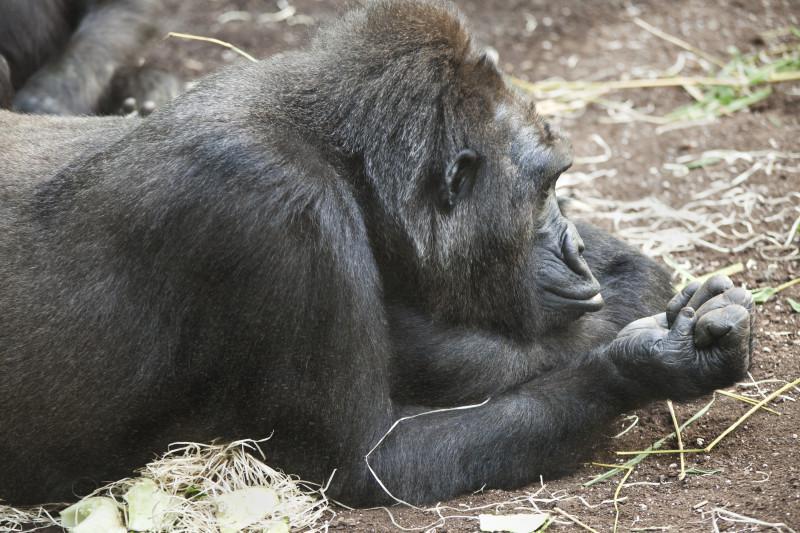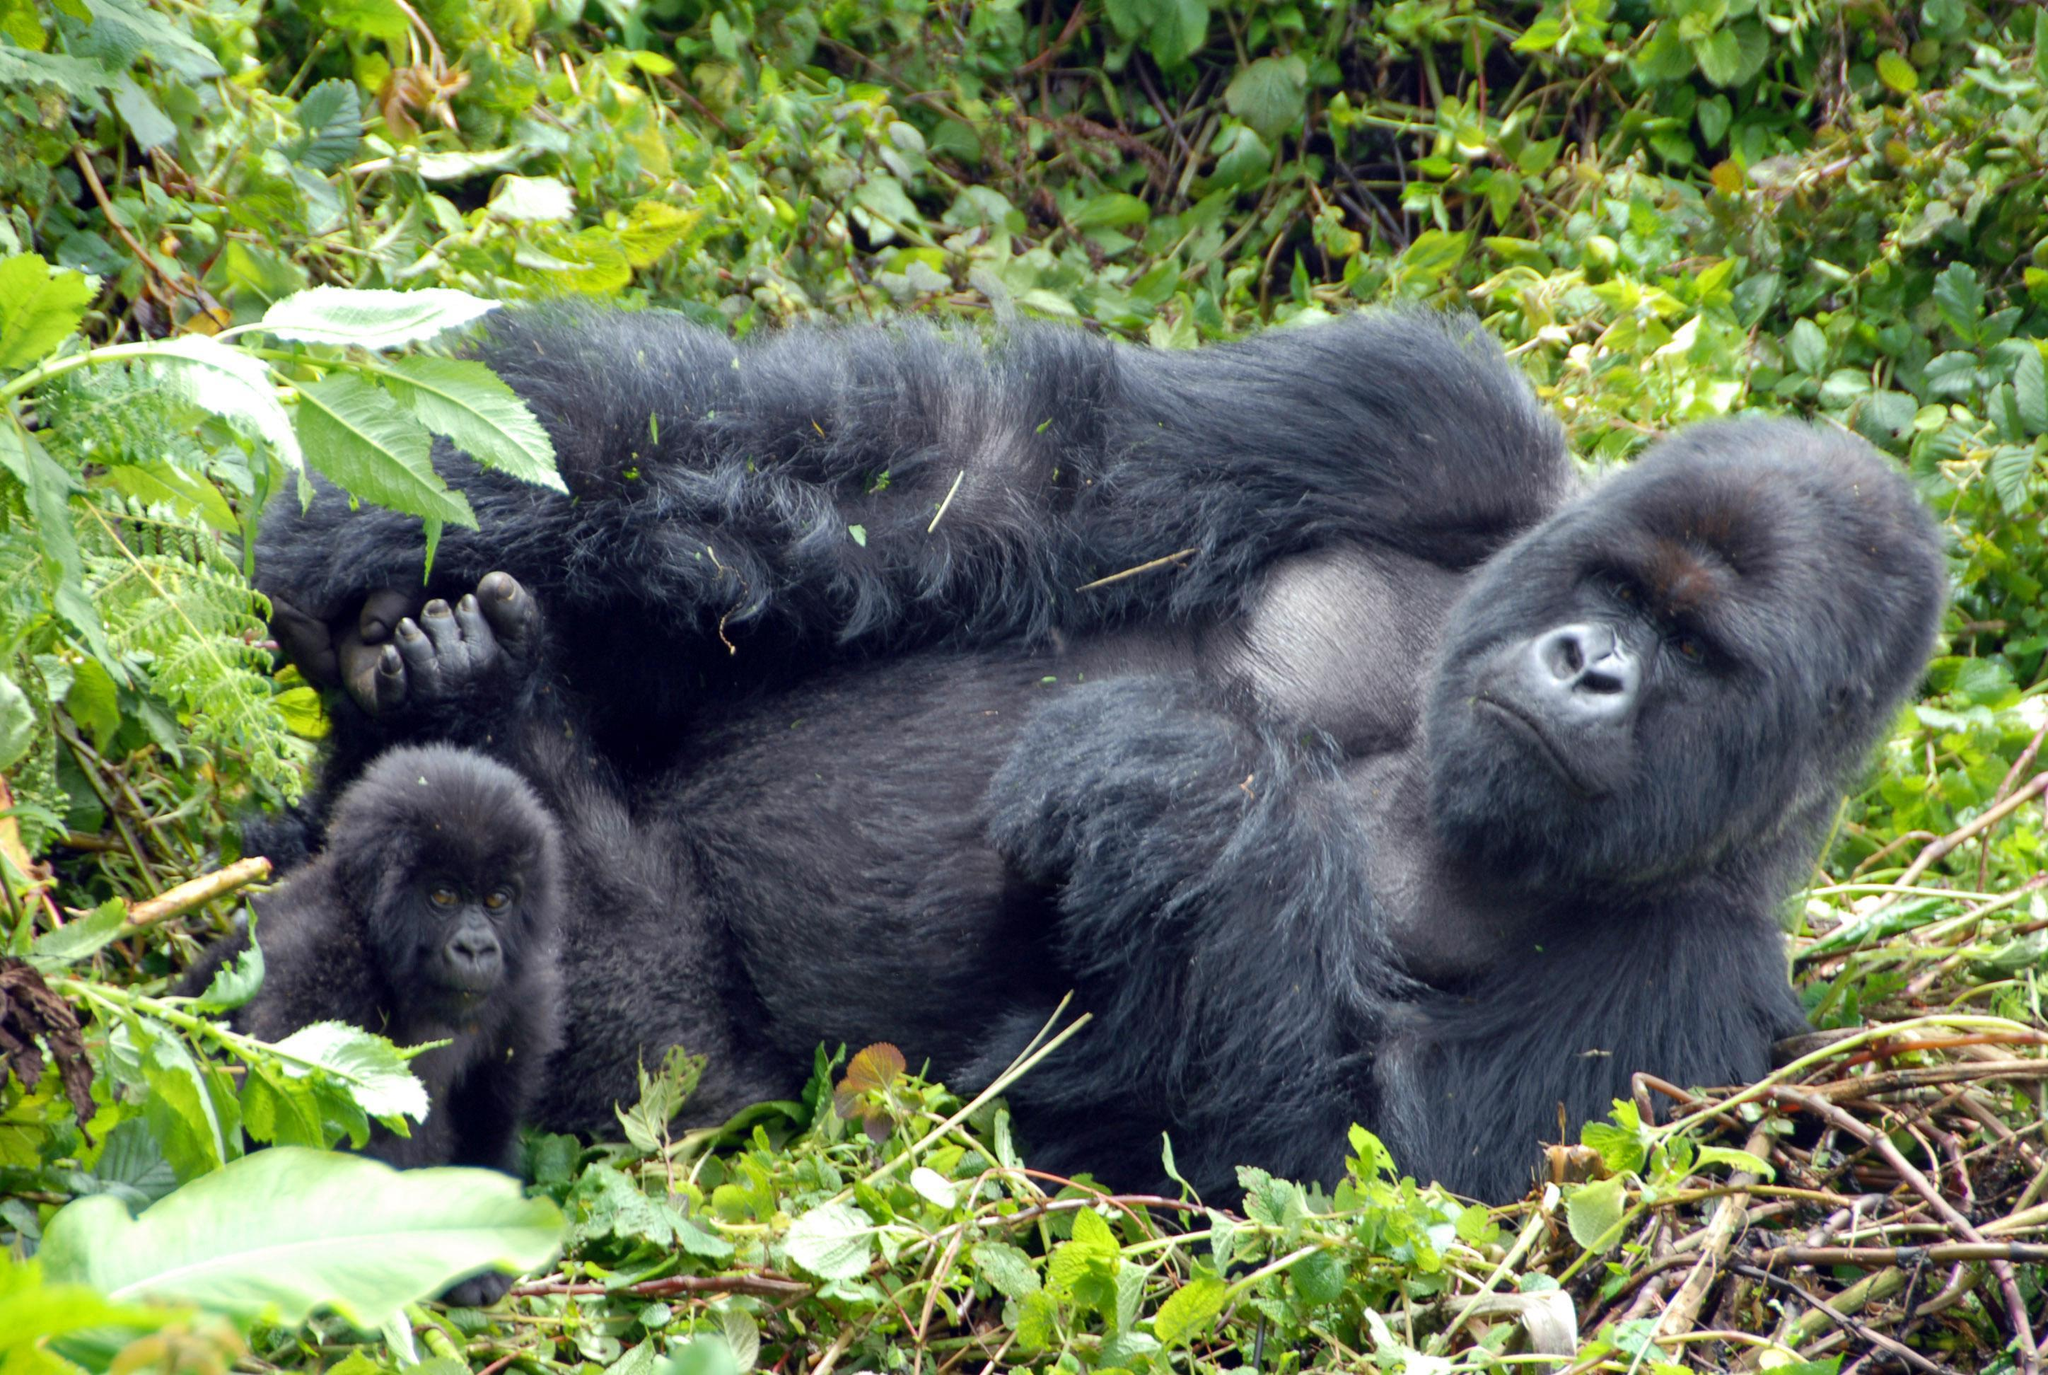The first image is the image on the left, the second image is the image on the right. Analyze the images presented: Is the assertion "One ape is laying on its stomach." valid? Answer yes or no. Yes. The first image is the image on the left, the second image is the image on the right. Analyze the images presented: Is the assertion "One image shows a forward-gazing gorilla reclining on its side with its head to the right, and the other image features a rightward-facing gorilla with its head in profile." valid? Answer yes or no. Yes. 